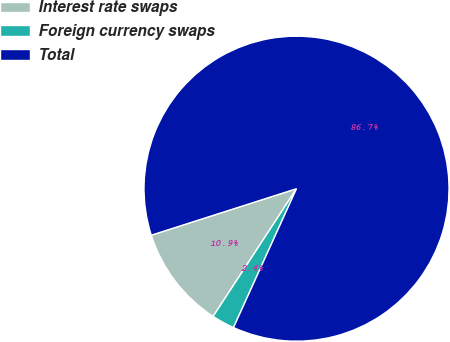<chart> <loc_0><loc_0><loc_500><loc_500><pie_chart><fcel>Interest rate swaps<fcel>Foreign currency swaps<fcel>Total<nl><fcel>10.86%<fcel>2.43%<fcel>86.71%<nl></chart> 